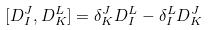Convert formula to latex. <formula><loc_0><loc_0><loc_500><loc_500>[ D _ { I } ^ { J } , D _ { K } ^ { L } ] = \delta _ { K } ^ { J } D _ { I } ^ { L } - \delta _ { I } ^ { L } D _ { K } ^ { J }</formula> 